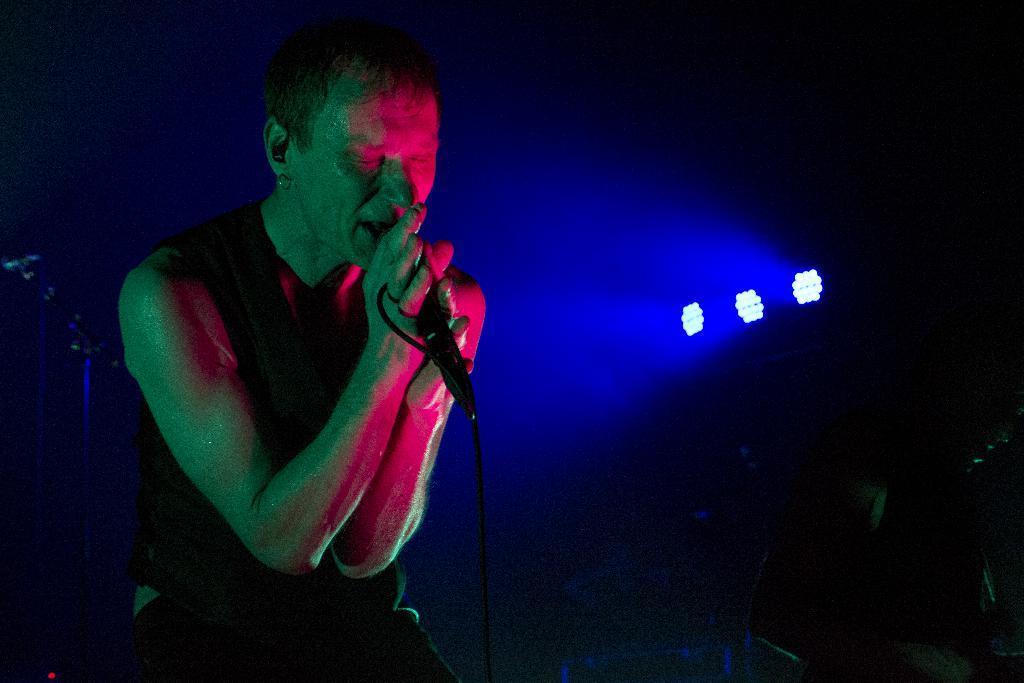Describe this image in one or two sentences. In this image, we can see a person holding a mic and in the background, there is a stand and we can see some lights. 